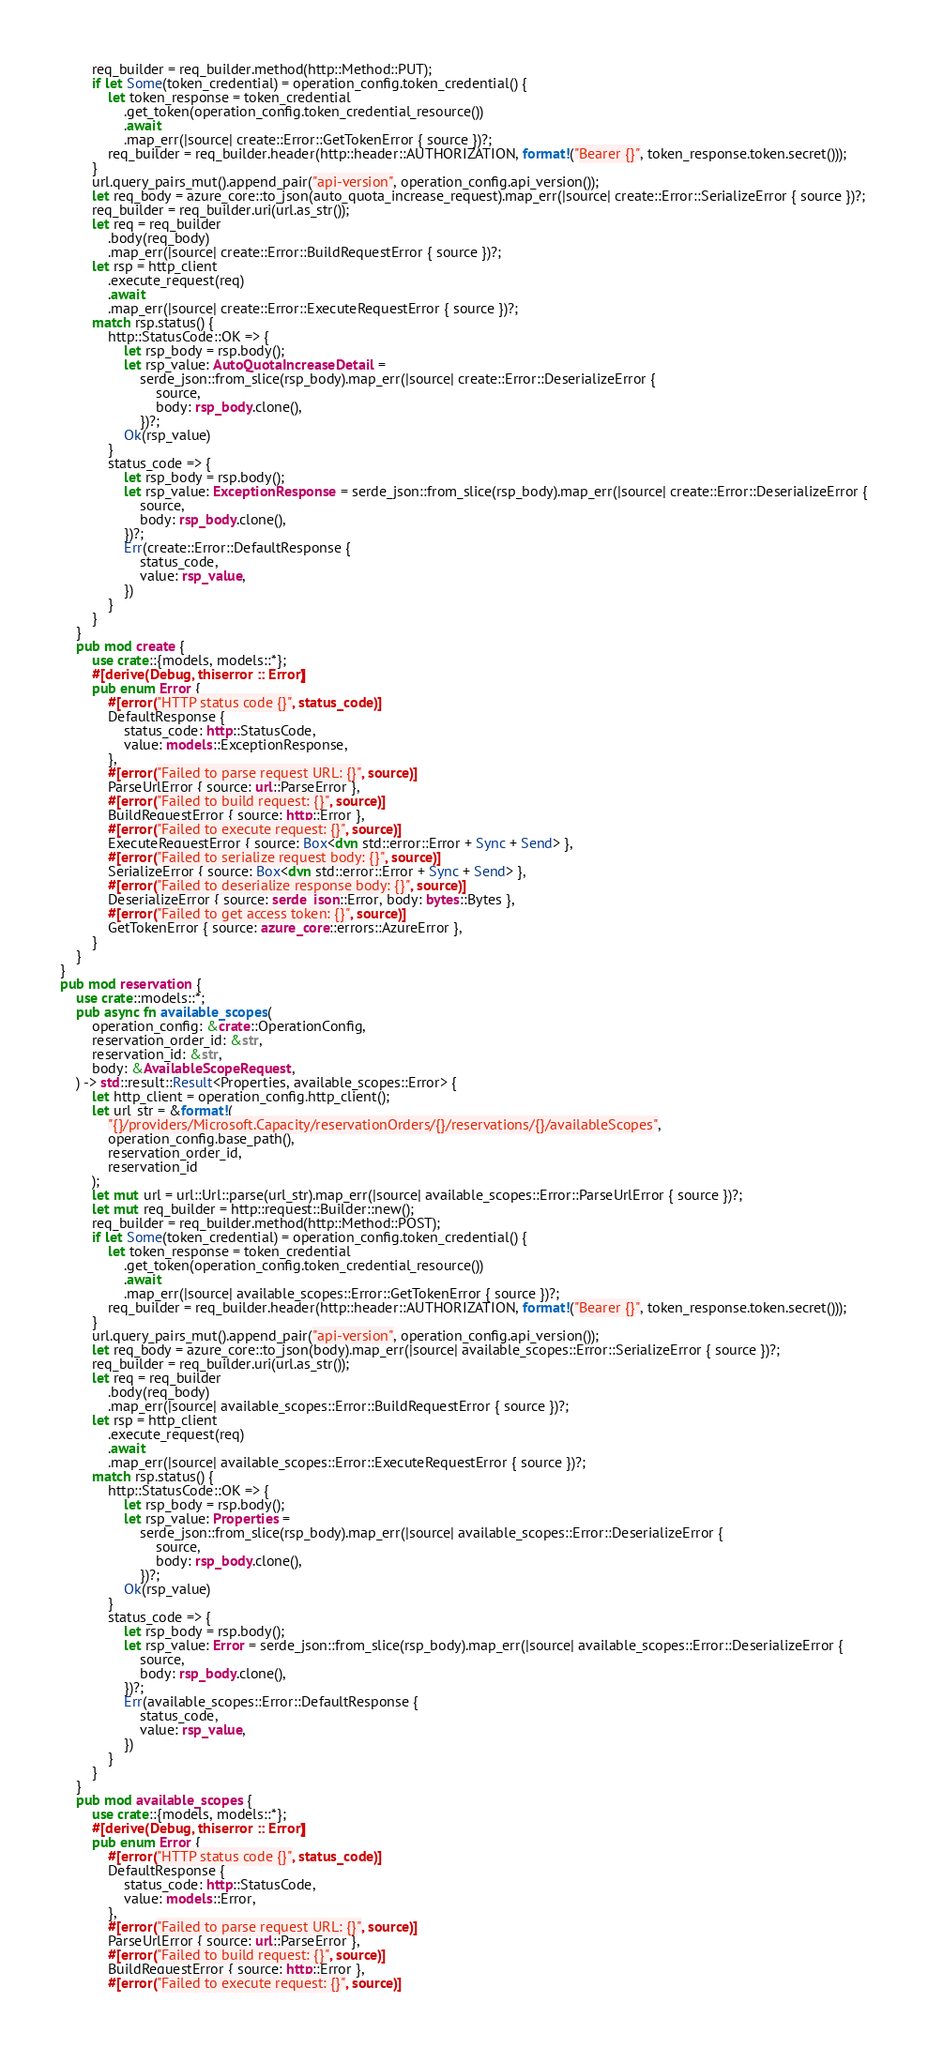<code> <loc_0><loc_0><loc_500><loc_500><_Rust_>        req_builder = req_builder.method(http::Method::PUT);
        if let Some(token_credential) = operation_config.token_credential() {
            let token_response = token_credential
                .get_token(operation_config.token_credential_resource())
                .await
                .map_err(|source| create::Error::GetTokenError { source })?;
            req_builder = req_builder.header(http::header::AUTHORIZATION, format!("Bearer {}", token_response.token.secret()));
        }
        url.query_pairs_mut().append_pair("api-version", operation_config.api_version());
        let req_body = azure_core::to_json(auto_quota_increase_request).map_err(|source| create::Error::SerializeError { source })?;
        req_builder = req_builder.uri(url.as_str());
        let req = req_builder
            .body(req_body)
            .map_err(|source| create::Error::BuildRequestError { source })?;
        let rsp = http_client
            .execute_request(req)
            .await
            .map_err(|source| create::Error::ExecuteRequestError { source })?;
        match rsp.status() {
            http::StatusCode::OK => {
                let rsp_body = rsp.body();
                let rsp_value: AutoQuotaIncreaseDetail =
                    serde_json::from_slice(rsp_body).map_err(|source| create::Error::DeserializeError {
                        source,
                        body: rsp_body.clone(),
                    })?;
                Ok(rsp_value)
            }
            status_code => {
                let rsp_body = rsp.body();
                let rsp_value: ExceptionResponse = serde_json::from_slice(rsp_body).map_err(|source| create::Error::DeserializeError {
                    source,
                    body: rsp_body.clone(),
                })?;
                Err(create::Error::DefaultResponse {
                    status_code,
                    value: rsp_value,
                })
            }
        }
    }
    pub mod create {
        use crate::{models, models::*};
        #[derive(Debug, thiserror :: Error)]
        pub enum Error {
            #[error("HTTP status code {}", status_code)]
            DefaultResponse {
                status_code: http::StatusCode,
                value: models::ExceptionResponse,
            },
            #[error("Failed to parse request URL: {}", source)]
            ParseUrlError { source: url::ParseError },
            #[error("Failed to build request: {}", source)]
            BuildRequestError { source: http::Error },
            #[error("Failed to execute request: {}", source)]
            ExecuteRequestError { source: Box<dyn std::error::Error + Sync + Send> },
            #[error("Failed to serialize request body: {}", source)]
            SerializeError { source: Box<dyn std::error::Error + Sync + Send> },
            #[error("Failed to deserialize response body: {}", source)]
            DeserializeError { source: serde_json::Error, body: bytes::Bytes },
            #[error("Failed to get access token: {}", source)]
            GetTokenError { source: azure_core::errors::AzureError },
        }
    }
}
pub mod reservation {
    use crate::models::*;
    pub async fn available_scopes(
        operation_config: &crate::OperationConfig,
        reservation_order_id: &str,
        reservation_id: &str,
        body: &AvailableScopeRequest,
    ) -> std::result::Result<Properties, available_scopes::Error> {
        let http_client = operation_config.http_client();
        let url_str = &format!(
            "{}/providers/Microsoft.Capacity/reservationOrders/{}/reservations/{}/availableScopes",
            operation_config.base_path(),
            reservation_order_id,
            reservation_id
        );
        let mut url = url::Url::parse(url_str).map_err(|source| available_scopes::Error::ParseUrlError { source })?;
        let mut req_builder = http::request::Builder::new();
        req_builder = req_builder.method(http::Method::POST);
        if let Some(token_credential) = operation_config.token_credential() {
            let token_response = token_credential
                .get_token(operation_config.token_credential_resource())
                .await
                .map_err(|source| available_scopes::Error::GetTokenError { source })?;
            req_builder = req_builder.header(http::header::AUTHORIZATION, format!("Bearer {}", token_response.token.secret()));
        }
        url.query_pairs_mut().append_pair("api-version", operation_config.api_version());
        let req_body = azure_core::to_json(body).map_err(|source| available_scopes::Error::SerializeError { source })?;
        req_builder = req_builder.uri(url.as_str());
        let req = req_builder
            .body(req_body)
            .map_err(|source| available_scopes::Error::BuildRequestError { source })?;
        let rsp = http_client
            .execute_request(req)
            .await
            .map_err(|source| available_scopes::Error::ExecuteRequestError { source })?;
        match rsp.status() {
            http::StatusCode::OK => {
                let rsp_body = rsp.body();
                let rsp_value: Properties =
                    serde_json::from_slice(rsp_body).map_err(|source| available_scopes::Error::DeserializeError {
                        source,
                        body: rsp_body.clone(),
                    })?;
                Ok(rsp_value)
            }
            status_code => {
                let rsp_body = rsp.body();
                let rsp_value: Error = serde_json::from_slice(rsp_body).map_err(|source| available_scopes::Error::DeserializeError {
                    source,
                    body: rsp_body.clone(),
                })?;
                Err(available_scopes::Error::DefaultResponse {
                    status_code,
                    value: rsp_value,
                })
            }
        }
    }
    pub mod available_scopes {
        use crate::{models, models::*};
        #[derive(Debug, thiserror :: Error)]
        pub enum Error {
            #[error("HTTP status code {}", status_code)]
            DefaultResponse {
                status_code: http::StatusCode,
                value: models::Error,
            },
            #[error("Failed to parse request URL: {}", source)]
            ParseUrlError { source: url::ParseError },
            #[error("Failed to build request: {}", source)]
            BuildRequestError { source: http::Error },
            #[error("Failed to execute request: {}", source)]</code> 